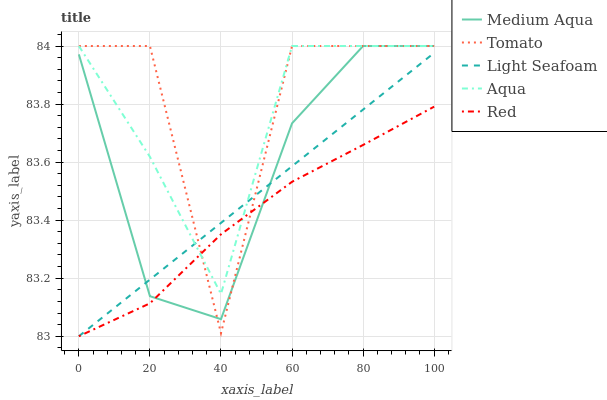Does Red have the minimum area under the curve?
Answer yes or no. Yes. Does Tomato have the maximum area under the curve?
Answer yes or no. Yes. Does Aqua have the minimum area under the curve?
Answer yes or no. No. Does Aqua have the maximum area under the curve?
Answer yes or no. No. Is Light Seafoam the smoothest?
Answer yes or no. Yes. Is Tomato the roughest?
Answer yes or no. Yes. Is Aqua the smoothest?
Answer yes or no. No. Is Aqua the roughest?
Answer yes or no. No. Does Light Seafoam have the lowest value?
Answer yes or no. Yes. Does Aqua have the lowest value?
Answer yes or no. No. Does Medium Aqua have the highest value?
Answer yes or no. Yes. Does Light Seafoam have the highest value?
Answer yes or no. No. Does Medium Aqua intersect Tomato?
Answer yes or no. Yes. Is Medium Aqua less than Tomato?
Answer yes or no. No. Is Medium Aqua greater than Tomato?
Answer yes or no. No. 